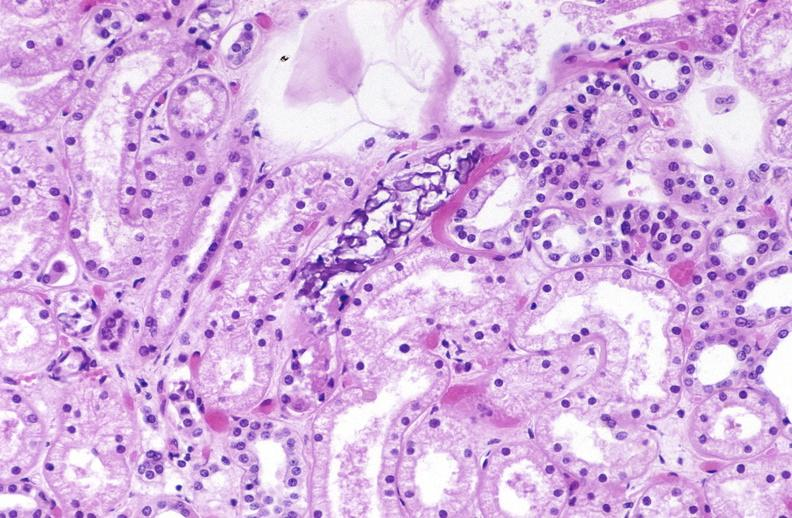what is present?
Answer the question using a single word or phrase. Urinary 